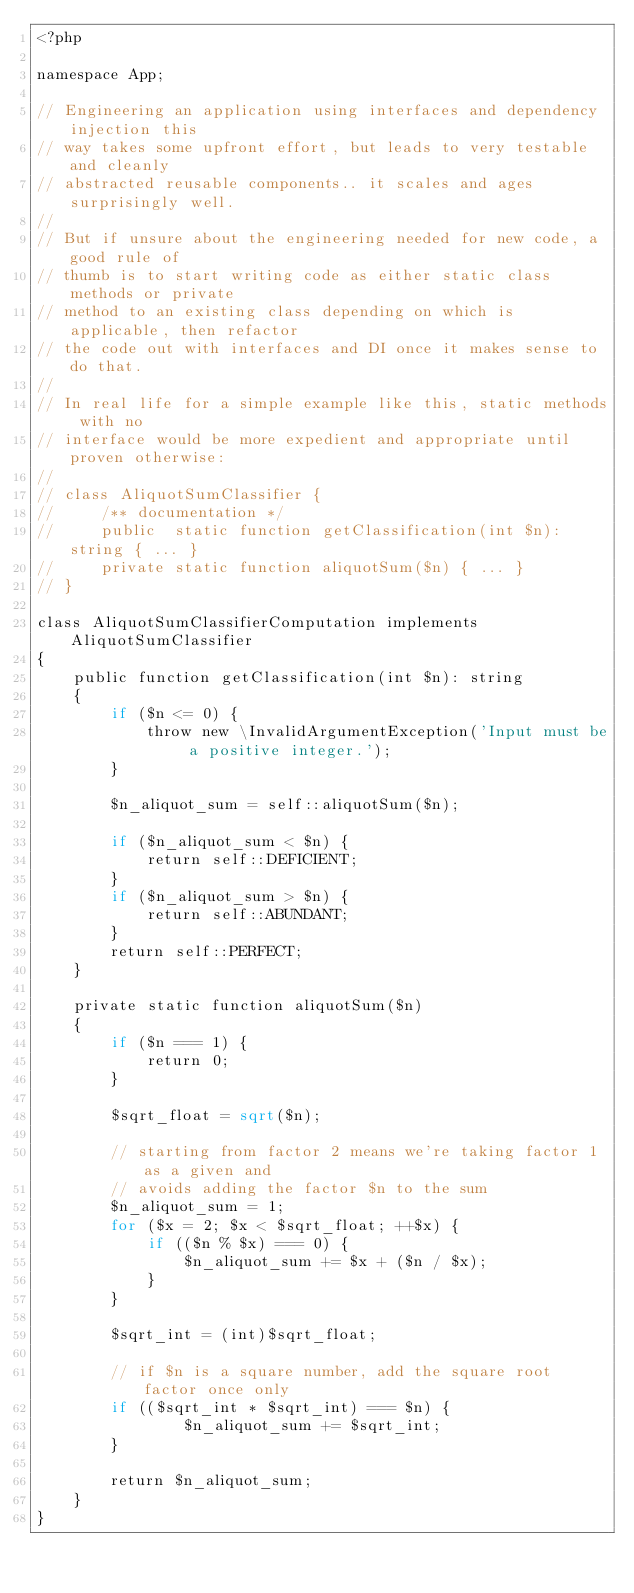Convert code to text. <code><loc_0><loc_0><loc_500><loc_500><_PHP_><?php

namespace App;

// Engineering an application using interfaces and dependency injection this
// way takes some upfront effort, but leads to very testable and cleanly
// abstracted reusable components.. it scales and ages surprisingly well.
//
// But if unsure about the engineering needed for new code, a good rule of
// thumb is to start writing code as either static class methods or private
// method to an existing class depending on which is applicable, then refactor
// the code out with interfaces and DI once it makes sense to do that.
//
// In real life for a simple example like this, static methods with no
// interface would be more expedient and appropriate until proven otherwise:
//
// class AliquotSumClassifier {
//     /** documentation */
//     public  static function getClassification(int $n): string { ... }
//     private static function aliquotSum($n) { ... }
// }

class AliquotSumClassifierComputation implements AliquotSumClassifier
{
    public function getClassification(int $n): string
    {
        if ($n <= 0) {
            throw new \InvalidArgumentException('Input must be a positive integer.');
        }

        $n_aliquot_sum = self::aliquotSum($n);

        if ($n_aliquot_sum < $n) {
            return self::DEFICIENT;
        }
        if ($n_aliquot_sum > $n) {
            return self::ABUNDANT;
        }
        return self::PERFECT;
    }

    private static function aliquotSum($n)
    {
        if ($n === 1) {
            return 0;
        }

        $sqrt_float = sqrt($n);

        // starting from factor 2 means we're taking factor 1 as a given and
        // avoids adding the factor $n to the sum
        $n_aliquot_sum = 1;
        for ($x = 2; $x < $sqrt_float; ++$x) {
            if (($n % $x) === 0) {
                $n_aliquot_sum += $x + ($n / $x);
            }
        }

        $sqrt_int = (int)$sqrt_float;

        // if $n is a square number, add the square root factor once only
        if (($sqrt_int * $sqrt_int) === $n) {
                $n_aliquot_sum += $sqrt_int;
        }

        return $n_aliquot_sum;
    }
}
</code> 